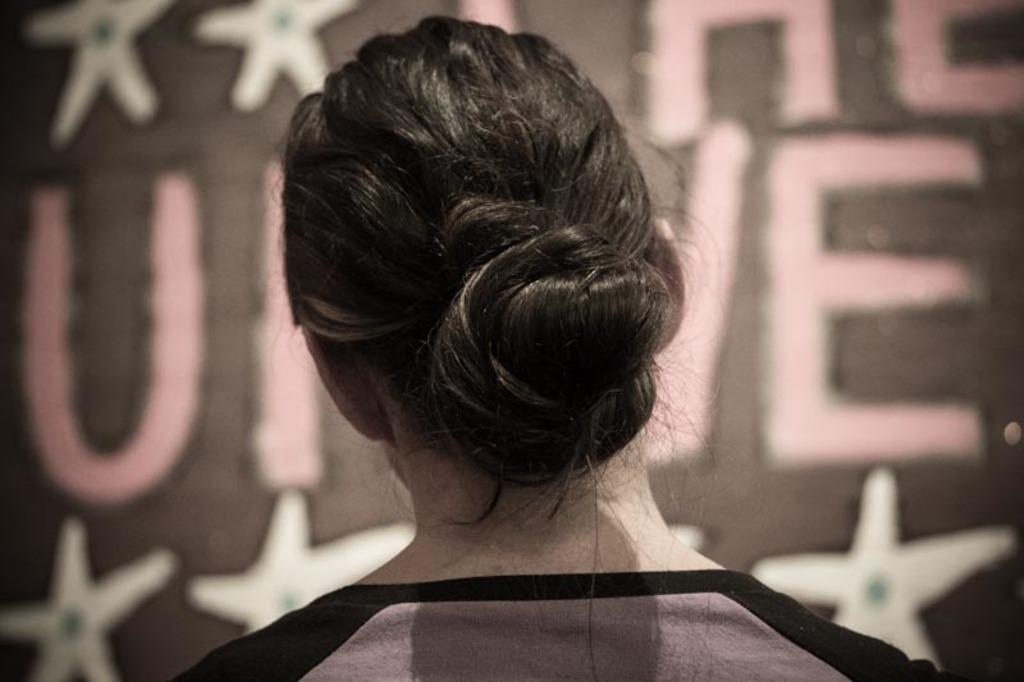What is the orientation of the person in the image? The person is facing away from the camera. What type of hairstyle does the person have? The person is wearing a bun. What can be seen in the background of the image? There are stars visible in the image. What is the cause of the pollution in the image? There is no pollution present in the image; it only features a person with a bun and stars in the background. 